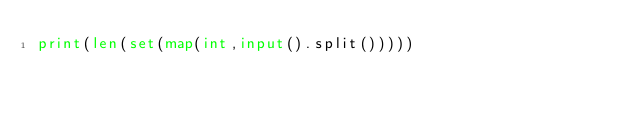<code> <loc_0><loc_0><loc_500><loc_500><_Python_>print(len(set(map(int,input().split()))))</code> 